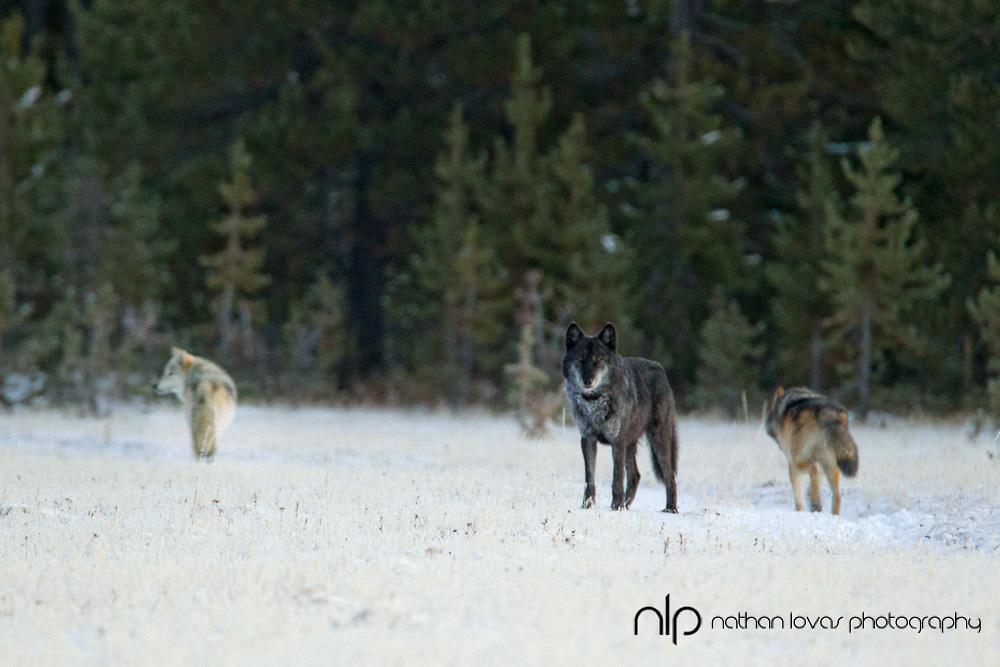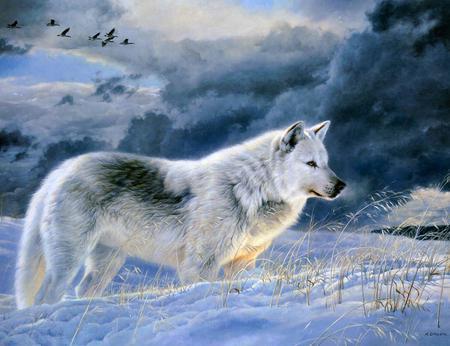The first image is the image on the left, the second image is the image on the right. Evaluate the accuracy of this statement regarding the images: "There is a single dog in one image and multiple dogs in the other image.". Is it true? Answer yes or no. Yes. The first image is the image on the left, the second image is the image on the right. For the images displayed, is the sentence "There is only one wolf in one of the images." factually correct? Answer yes or no. Yes. 